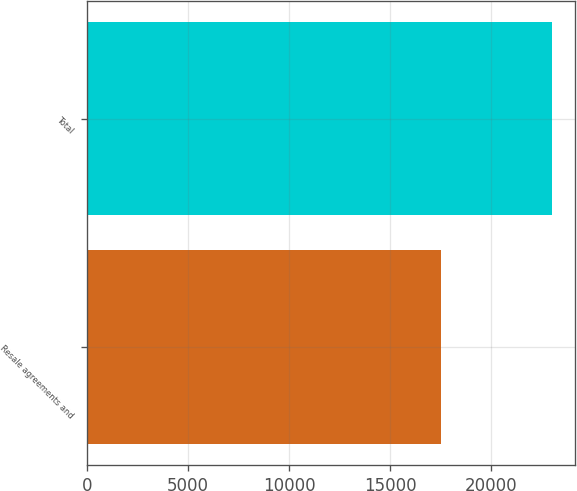Convert chart. <chart><loc_0><loc_0><loc_500><loc_500><bar_chart><fcel>Resale agreements and<fcel>Total<nl><fcel>17521<fcel>22997<nl></chart> 